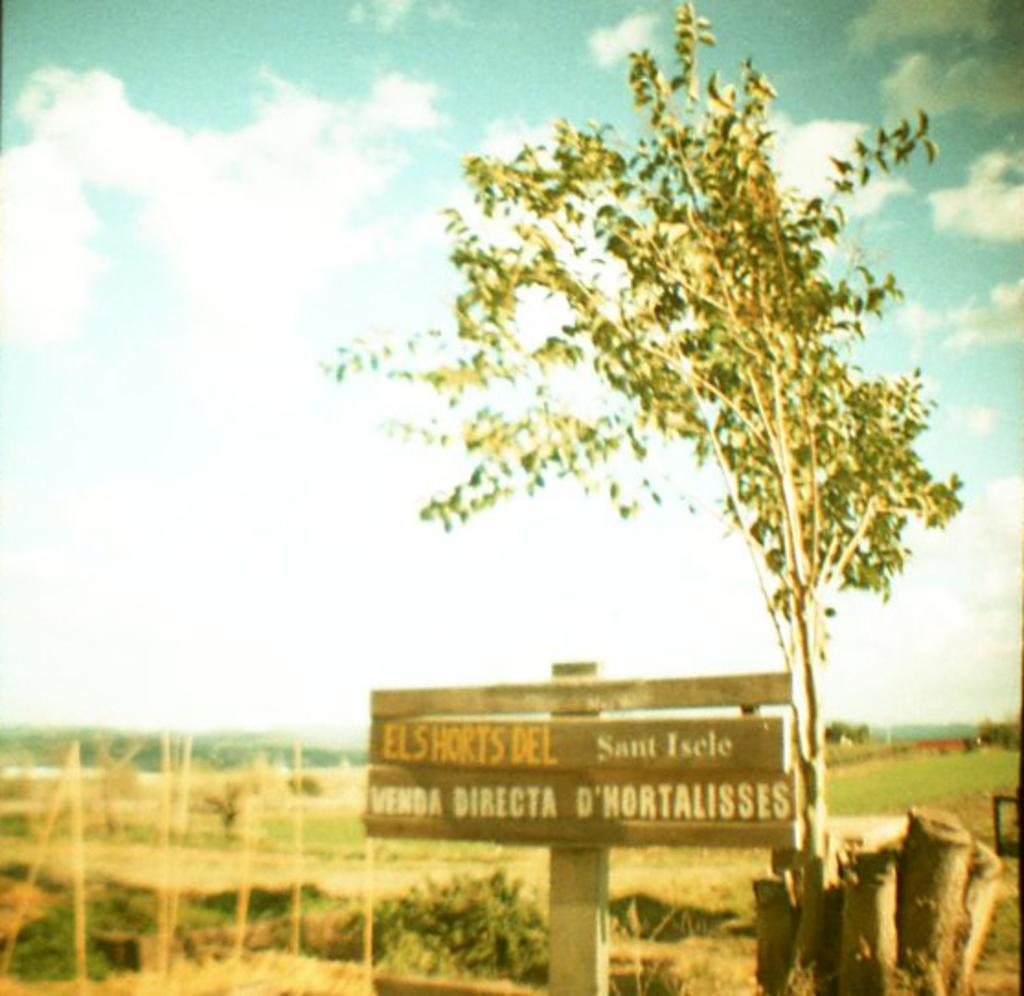What is attached to the pole in the image? There is a board attached to the pole in the image. What type of plant can be seen in the image? There is a tree in the image. What material are the poles made of? The poles in the image are made of wood. What can be seen in the background of the image? The ground, grass, trees, and sky are visible in the background of the image. What type of bird is sitting on the book in the image? There is no bird or book present in the image. How does the light affect the visibility of the wooden poles in the image? There is no mention of light in the provided facts, so we cannot determine how it affects the visibility of the wooden poles in the image. 